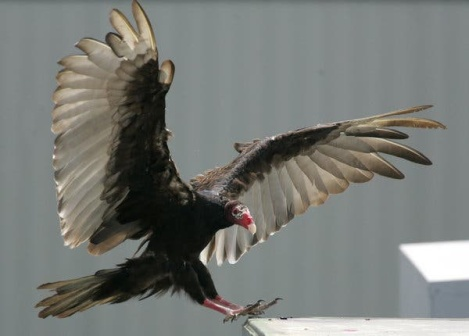Can you create a short story involving the vulture and the building? In a small town, an old gray building with a white roof was home to a myriad of stories. One day, a turkey vulture found its way to the rooftop. Drawn by the quiet solitude, it soon made this place its frequent perch. The townsfolk, initially wary, grew to welcome this visitor, who seemed to guard the old building. Legends began to form around the vulture, tales of it bringing good fortune and watching over the townspeople. The bird became a symbol of resilience and mystery, a reminder of the wild weaving into the fabric of everyday life, enriching the community’s collective story. 